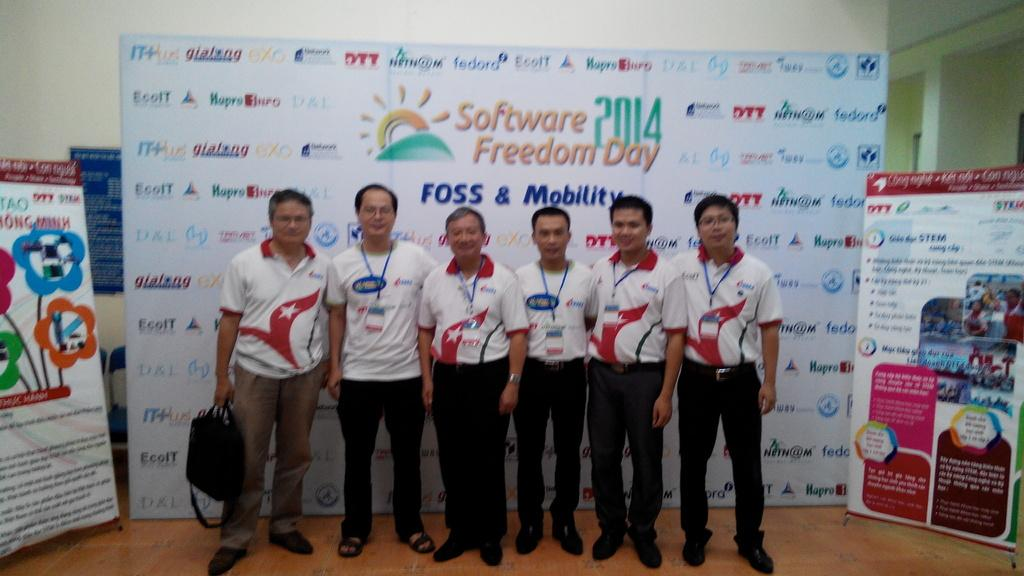<image>
Render a clear and concise summary of the photo. men in corporate clothes stand in front of board with Software Freedom Day written on it 